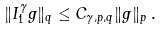Convert formula to latex. <formula><loc_0><loc_0><loc_500><loc_500>\| I ^ { \gamma } _ { 1 } g \| _ { q } \leq C _ { \gamma , p , q } \| g \| _ { p } \, .</formula> 